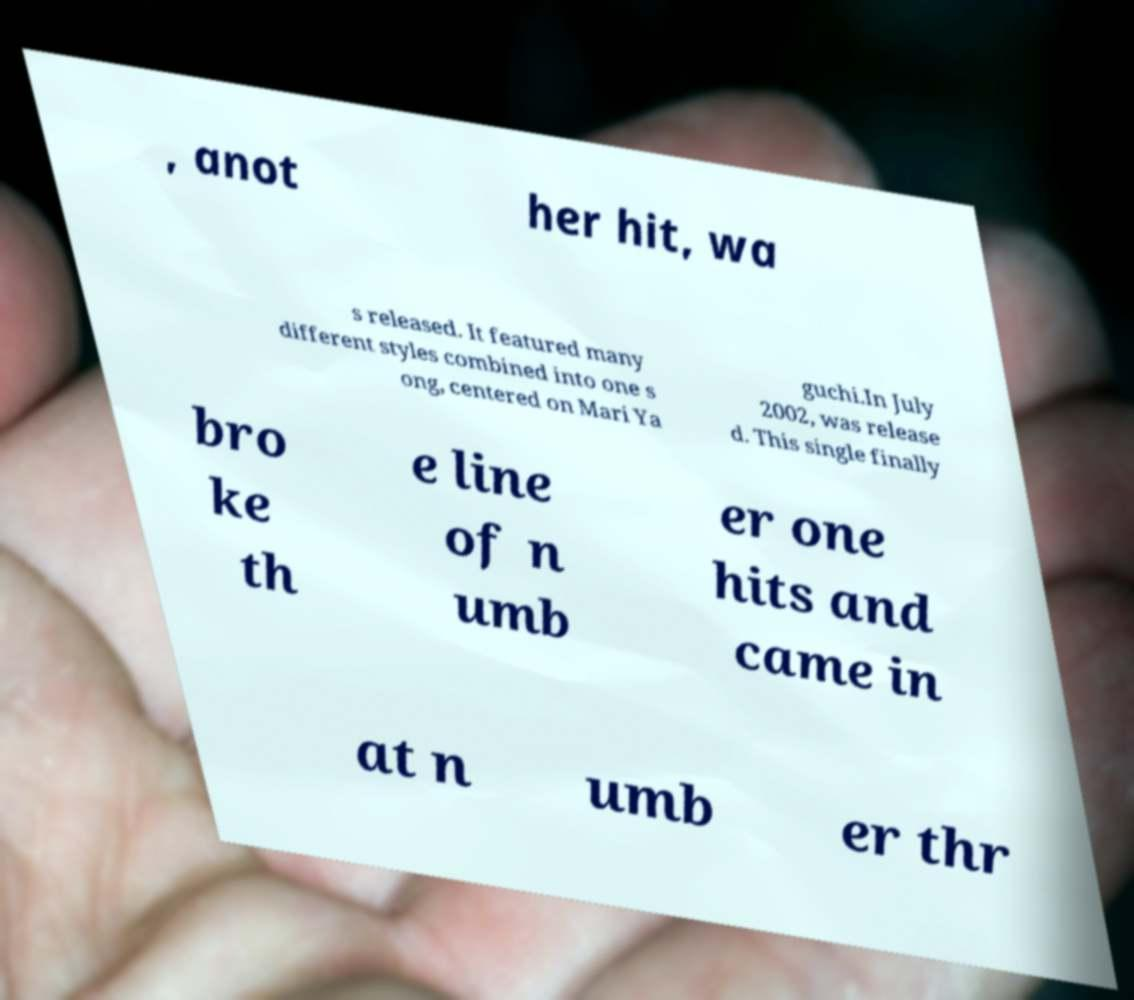Could you extract and type out the text from this image? , anot her hit, wa s released. It featured many different styles combined into one s ong, centered on Mari Ya guchi.In July 2002, was release d. This single finally bro ke th e line of n umb er one hits and came in at n umb er thr 